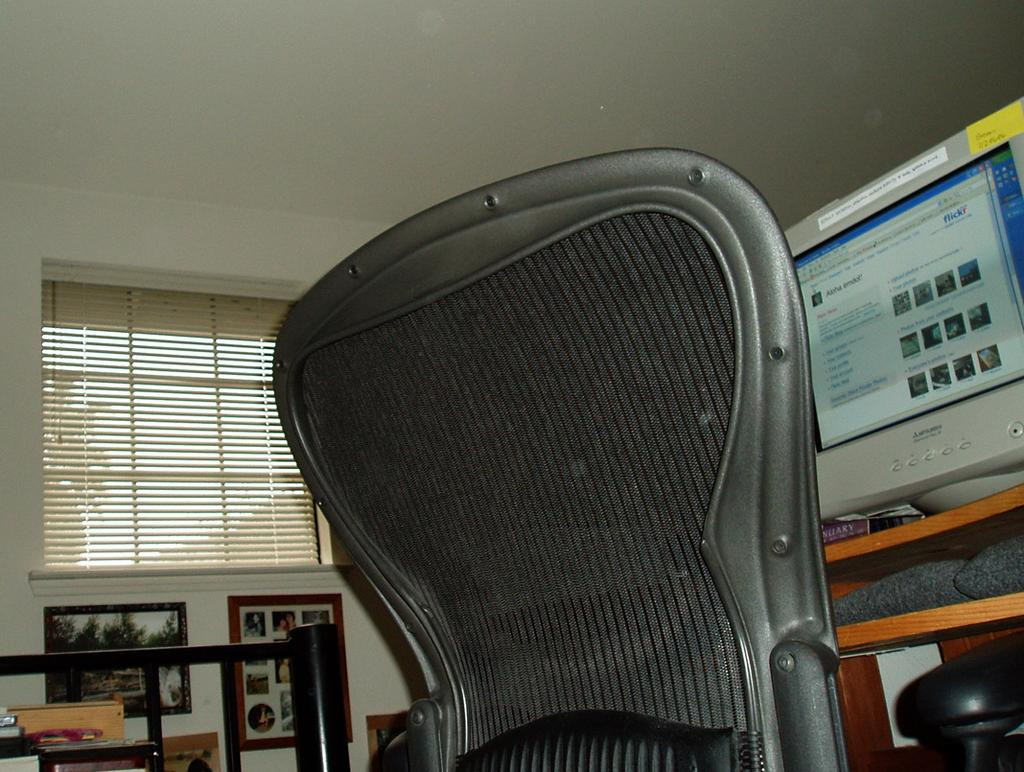What type of furniture is present in the image? There is a chair in the image. What electronic device can be seen in the image? There is a monitor in the image. Are there any decorative items on the wall in the image? Yes, there are photo frames on the wall in the image. What is visible at the top of the image? The sky is visible at the top of the image. Can you tell me how many coastlines are visible in the image? There are no coastlines visible in the image; it features a chair, a monitor, photo frames, and the sky. What type of coil is present in the image? There is no coil present in the image. 